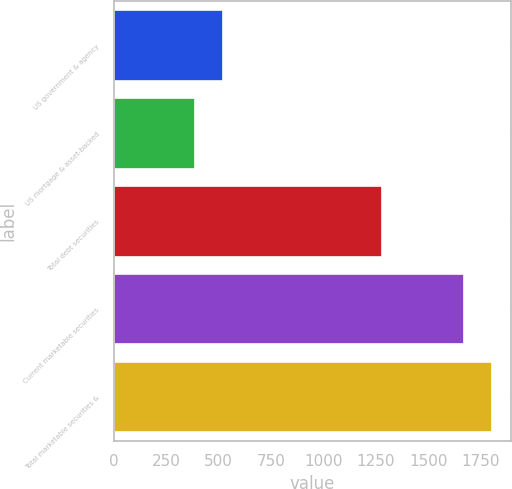<chart> <loc_0><loc_0><loc_500><loc_500><bar_chart><fcel>US government & agency<fcel>US mortgage & asset-backed<fcel>Total debt securities<fcel>Current marketable securities<fcel>Total marketable securities &<nl><fcel>520.1<fcel>389<fcel>1280<fcel>1672<fcel>1803.1<nl></chart> 